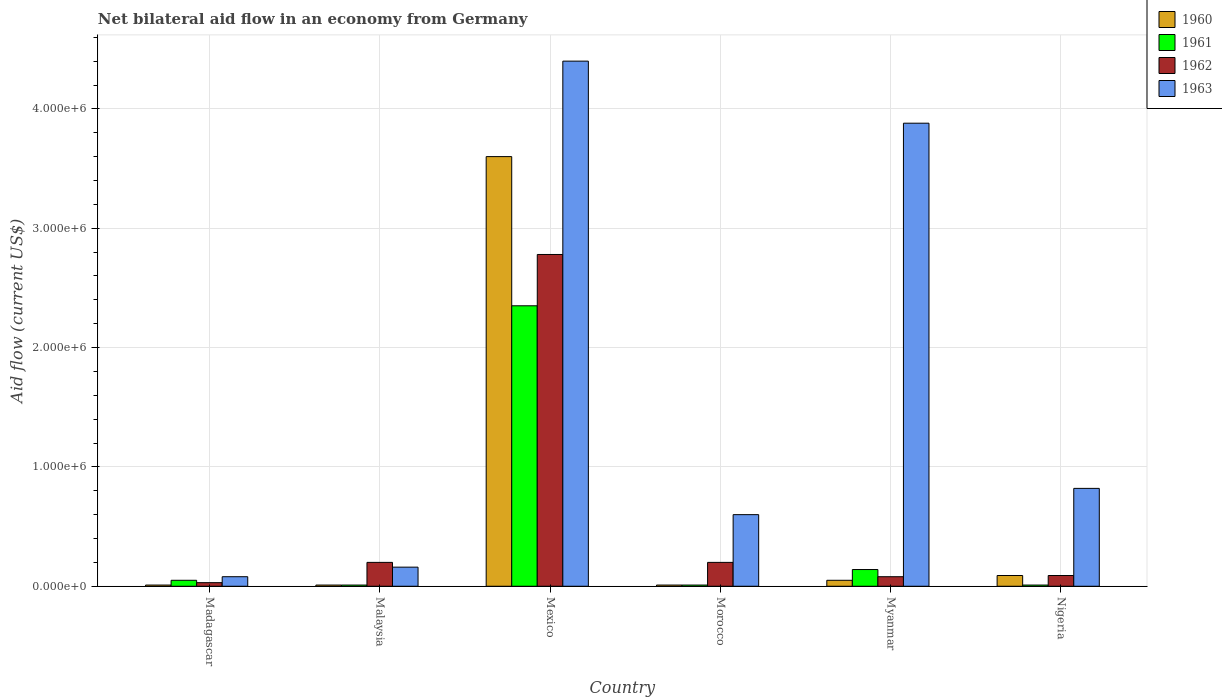Are the number of bars per tick equal to the number of legend labels?
Provide a succinct answer. Yes. What is the label of the 4th group of bars from the left?
Ensure brevity in your answer.  Morocco. What is the net bilateral aid flow in 1963 in Mexico?
Offer a very short reply. 4.40e+06. Across all countries, what is the maximum net bilateral aid flow in 1962?
Ensure brevity in your answer.  2.78e+06. In which country was the net bilateral aid flow in 1963 minimum?
Your answer should be compact. Madagascar. What is the total net bilateral aid flow in 1961 in the graph?
Provide a succinct answer. 2.57e+06. What is the difference between the net bilateral aid flow in 1962 in Madagascar and that in Malaysia?
Offer a terse response. -1.70e+05. What is the difference between the net bilateral aid flow in 1961 in Mexico and the net bilateral aid flow in 1960 in Morocco?
Provide a short and direct response. 2.34e+06. What is the average net bilateral aid flow in 1962 per country?
Provide a short and direct response. 5.63e+05. What is the difference between the net bilateral aid flow of/in 1963 and net bilateral aid flow of/in 1962 in Madagascar?
Offer a terse response. 5.00e+04. In how many countries, is the net bilateral aid flow in 1960 greater than 3000000 US$?
Offer a terse response. 1. What is the ratio of the net bilateral aid flow in 1960 in Madagascar to that in Nigeria?
Make the answer very short. 0.11. Is the difference between the net bilateral aid flow in 1963 in Malaysia and Nigeria greater than the difference between the net bilateral aid flow in 1962 in Malaysia and Nigeria?
Your answer should be compact. No. What is the difference between the highest and the second highest net bilateral aid flow in 1962?
Keep it short and to the point. 2.58e+06. What is the difference between the highest and the lowest net bilateral aid flow in 1961?
Your answer should be very brief. 2.34e+06. What does the 4th bar from the left in Madagascar represents?
Ensure brevity in your answer.  1963. What does the 1st bar from the right in Malaysia represents?
Offer a terse response. 1963. How many bars are there?
Your answer should be compact. 24. How many countries are there in the graph?
Ensure brevity in your answer.  6. What is the difference between two consecutive major ticks on the Y-axis?
Offer a very short reply. 1.00e+06. Are the values on the major ticks of Y-axis written in scientific E-notation?
Provide a short and direct response. Yes. Does the graph contain grids?
Provide a short and direct response. Yes. Where does the legend appear in the graph?
Give a very brief answer. Top right. How are the legend labels stacked?
Provide a succinct answer. Vertical. What is the title of the graph?
Provide a short and direct response. Net bilateral aid flow in an economy from Germany. What is the label or title of the Y-axis?
Keep it short and to the point. Aid flow (current US$). What is the Aid flow (current US$) in 1962 in Madagascar?
Make the answer very short. 3.00e+04. What is the Aid flow (current US$) in 1963 in Madagascar?
Provide a short and direct response. 8.00e+04. What is the Aid flow (current US$) in 1963 in Malaysia?
Your answer should be very brief. 1.60e+05. What is the Aid flow (current US$) of 1960 in Mexico?
Provide a short and direct response. 3.60e+06. What is the Aid flow (current US$) of 1961 in Mexico?
Your answer should be compact. 2.35e+06. What is the Aid flow (current US$) of 1962 in Mexico?
Make the answer very short. 2.78e+06. What is the Aid flow (current US$) of 1963 in Mexico?
Keep it short and to the point. 4.40e+06. What is the Aid flow (current US$) of 1961 in Morocco?
Ensure brevity in your answer.  10000. What is the Aid flow (current US$) in 1962 in Morocco?
Offer a terse response. 2.00e+05. What is the Aid flow (current US$) in 1963 in Morocco?
Provide a succinct answer. 6.00e+05. What is the Aid flow (current US$) in 1961 in Myanmar?
Your response must be concise. 1.40e+05. What is the Aid flow (current US$) in 1963 in Myanmar?
Ensure brevity in your answer.  3.88e+06. What is the Aid flow (current US$) of 1960 in Nigeria?
Provide a succinct answer. 9.00e+04. What is the Aid flow (current US$) in 1963 in Nigeria?
Keep it short and to the point. 8.20e+05. Across all countries, what is the maximum Aid flow (current US$) in 1960?
Provide a short and direct response. 3.60e+06. Across all countries, what is the maximum Aid flow (current US$) of 1961?
Keep it short and to the point. 2.35e+06. Across all countries, what is the maximum Aid flow (current US$) of 1962?
Make the answer very short. 2.78e+06. Across all countries, what is the maximum Aid flow (current US$) in 1963?
Provide a succinct answer. 4.40e+06. Across all countries, what is the minimum Aid flow (current US$) in 1962?
Your answer should be very brief. 3.00e+04. What is the total Aid flow (current US$) of 1960 in the graph?
Your response must be concise. 3.77e+06. What is the total Aid flow (current US$) in 1961 in the graph?
Make the answer very short. 2.57e+06. What is the total Aid flow (current US$) in 1962 in the graph?
Ensure brevity in your answer.  3.38e+06. What is the total Aid flow (current US$) in 1963 in the graph?
Offer a terse response. 9.94e+06. What is the difference between the Aid flow (current US$) of 1962 in Madagascar and that in Malaysia?
Ensure brevity in your answer.  -1.70e+05. What is the difference between the Aid flow (current US$) of 1963 in Madagascar and that in Malaysia?
Give a very brief answer. -8.00e+04. What is the difference between the Aid flow (current US$) in 1960 in Madagascar and that in Mexico?
Ensure brevity in your answer.  -3.59e+06. What is the difference between the Aid flow (current US$) of 1961 in Madagascar and that in Mexico?
Provide a succinct answer. -2.30e+06. What is the difference between the Aid flow (current US$) in 1962 in Madagascar and that in Mexico?
Offer a very short reply. -2.75e+06. What is the difference between the Aid flow (current US$) in 1963 in Madagascar and that in Mexico?
Offer a very short reply. -4.32e+06. What is the difference between the Aid flow (current US$) of 1961 in Madagascar and that in Morocco?
Provide a succinct answer. 4.00e+04. What is the difference between the Aid flow (current US$) of 1963 in Madagascar and that in Morocco?
Your answer should be very brief. -5.20e+05. What is the difference between the Aid flow (current US$) in 1960 in Madagascar and that in Myanmar?
Your answer should be compact. -4.00e+04. What is the difference between the Aid flow (current US$) of 1961 in Madagascar and that in Myanmar?
Your answer should be compact. -9.00e+04. What is the difference between the Aid flow (current US$) of 1962 in Madagascar and that in Myanmar?
Keep it short and to the point. -5.00e+04. What is the difference between the Aid flow (current US$) of 1963 in Madagascar and that in Myanmar?
Your answer should be compact. -3.80e+06. What is the difference between the Aid flow (current US$) of 1960 in Madagascar and that in Nigeria?
Make the answer very short. -8.00e+04. What is the difference between the Aid flow (current US$) of 1961 in Madagascar and that in Nigeria?
Give a very brief answer. 4.00e+04. What is the difference between the Aid flow (current US$) of 1963 in Madagascar and that in Nigeria?
Provide a short and direct response. -7.40e+05. What is the difference between the Aid flow (current US$) of 1960 in Malaysia and that in Mexico?
Offer a very short reply. -3.59e+06. What is the difference between the Aid flow (current US$) of 1961 in Malaysia and that in Mexico?
Ensure brevity in your answer.  -2.34e+06. What is the difference between the Aid flow (current US$) in 1962 in Malaysia and that in Mexico?
Provide a succinct answer. -2.58e+06. What is the difference between the Aid flow (current US$) of 1963 in Malaysia and that in Mexico?
Give a very brief answer. -4.24e+06. What is the difference between the Aid flow (current US$) in 1961 in Malaysia and that in Morocco?
Your answer should be very brief. 0. What is the difference between the Aid flow (current US$) of 1963 in Malaysia and that in Morocco?
Provide a short and direct response. -4.40e+05. What is the difference between the Aid flow (current US$) of 1960 in Malaysia and that in Myanmar?
Provide a short and direct response. -4.00e+04. What is the difference between the Aid flow (current US$) of 1961 in Malaysia and that in Myanmar?
Offer a very short reply. -1.30e+05. What is the difference between the Aid flow (current US$) of 1962 in Malaysia and that in Myanmar?
Offer a terse response. 1.20e+05. What is the difference between the Aid flow (current US$) of 1963 in Malaysia and that in Myanmar?
Your response must be concise. -3.72e+06. What is the difference between the Aid flow (current US$) of 1963 in Malaysia and that in Nigeria?
Give a very brief answer. -6.60e+05. What is the difference between the Aid flow (current US$) of 1960 in Mexico and that in Morocco?
Offer a terse response. 3.59e+06. What is the difference between the Aid flow (current US$) of 1961 in Mexico and that in Morocco?
Make the answer very short. 2.34e+06. What is the difference between the Aid flow (current US$) of 1962 in Mexico and that in Morocco?
Your response must be concise. 2.58e+06. What is the difference between the Aid flow (current US$) in 1963 in Mexico and that in Morocco?
Ensure brevity in your answer.  3.80e+06. What is the difference between the Aid flow (current US$) of 1960 in Mexico and that in Myanmar?
Your answer should be compact. 3.55e+06. What is the difference between the Aid flow (current US$) of 1961 in Mexico and that in Myanmar?
Offer a very short reply. 2.21e+06. What is the difference between the Aid flow (current US$) of 1962 in Mexico and that in Myanmar?
Keep it short and to the point. 2.70e+06. What is the difference between the Aid flow (current US$) in 1963 in Mexico and that in Myanmar?
Ensure brevity in your answer.  5.20e+05. What is the difference between the Aid flow (current US$) of 1960 in Mexico and that in Nigeria?
Ensure brevity in your answer.  3.51e+06. What is the difference between the Aid flow (current US$) of 1961 in Mexico and that in Nigeria?
Offer a very short reply. 2.34e+06. What is the difference between the Aid flow (current US$) in 1962 in Mexico and that in Nigeria?
Provide a succinct answer. 2.69e+06. What is the difference between the Aid flow (current US$) of 1963 in Mexico and that in Nigeria?
Your response must be concise. 3.58e+06. What is the difference between the Aid flow (current US$) in 1961 in Morocco and that in Myanmar?
Give a very brief answer. -1.30e+05. What is the difference between the Aid flow (current US$) in 1962 in Morocco and that in Myanmar?
Your answer should be compact. 1.20e+05. What is the difference between the Aid flow (current US$) in 1963 in Morocco and that in Myanmar?
Keep it short and to the point. -3.28e+06. What is the difference between the Aid flow (current US$) of 1960 in Morocco and that in Nigeria?
Give a very brief answer. -8.00e+04. What is the difference between the Aid flow (current US$) in 1961 in Morocco and that in Nigeria?
Your response must be concise. 0. What is the difference between the Aid flow (current US$) in 1963 in Morocco and that in Nigeria?
Provide a succinct answer. -2.20e+05. What is the difference between the Aid flow (current US$) in 1961 in Myanmar and that in Nigeria?
Provide a short and direct response. 1.30e+05. What is the difference between the Aid flow (current US$) of 1962 in Myanmar and that in Nigeria?
Your response must be concise. -10000. What is the difference between the Aid flow (current US$) of 1963 in Myanmar and that in Nigeria?
Offer a very short reply. 3.06e+06. What is the difference between the Aid flow (current US$) in 1960 in Madagascar and the Aid flow (current US$) in 1961 in Malaysia?
Provide a succinct answer. 0. What is the difference between the Aid flow (current US$) of 1960 in Madagascar and the Aid flow (current US$) of 1962 in Malaysia?
Ensure brevity in your answer.  -1.90e+05. What is the difference between the Aid flow (current US$) in 1960 in Madagascar and the Aid flow (current US$) in 1963 in Malaysia?
Offer a very short reply. -1.50e+05. What is the difference between the Aid flow (current US$) of 1961 in Madagascar and the Aid flow (current US$) of 1962 in Malaysia?
Provide a succinct answer. -1.50e+05. What is the difference between the Aid flow (current US$) in 1962 in Madagascar and the Aid flow (current US$) in 1963 in Malaysia?
Your answer should be compact. -1.30e+05. What is the difference between the Aid flow (current US$) in 1960 in Madagascar and the Aid flow (current US$) in 1961 in Mexico?
Offer a very short reply. -2.34e+06. What is the difference between the Aid flow (current US$) of 1960 in Madagascar and the Aid flow (current US$) of 1962 in Mexico?
Offer a terse response. -2.77e+06. What is the difference between the Aid flow (current US$) in 1960 in Madagascar and the Aid flow (current US$) in 1963 in Mexico?
Your answer should be compact. -4.39e+06. What is the difference between the Aid flow (current US$) of 1961 in Madagascar and the Aid flow (current US$) of 1962 in Mexico?
Your answer should be compact. -2.73e+06. What is the difference between the Aid flow (current US$) in 1961 in Madagascar and the Aid flow (current US$) in 1963 in Mexico?
Offer a very short reply. -4.35e+06. What is the difference between the Aid flow (current US$) of 1962 in Madagascar and the Aid flow (current US$) of 1963 in Mexico?
Make the answer very short. -4.37e+06. What is the difference between the Aid flow (current US$) in 1960 in Madagascar and the Aid flow (current US$) in 1962 in Morocco?
Provide a short and direct response. -1.90e+05. What is the difference between the Aid flow (current US$) in 1960 in Madagascar and the Aid flow (current US$) in 1963 in Morocco?
Provide a succinct answer. -5.90e+05. What is the difference between the Aid flow (current US$) of 1961 in Madagascar and the Aid flow (current US$) of 1963 in Morocco?
Your response must be concise. -5.50e+05. What is the difference between the Aid flow (current US$) of 1962 in Madagascar and the Aid flow (current US$) of 1963 in Morocco?
Your response must be concise. -5.70e+05. What is the difference between the Aid flow (current US$) in 1960 in Madagascar and the Aid flow (current US$) in 1961 in Myanmar?
Keep it short and to the point. -1.30e+05. What is the difference between the Aid flow (current US$) of 1960 in Madagascar and the Aid flow (current US$) of 1963 in Myanmar?
Keep it short and to the point. -3.87e+06. What is the difference between the Aid flow (current US$) of 1961 in Madagascar and the Aid flow (current US$) of 1963 in Myanmar?
Your response must be concise. -3.83e+06. What is the difference between the Aid flow (current US$) in 1962 in Madagascar and the Aid flow (current US$) in 1963 in Myanmar?
Provide a short and direct response. -3.85e+06. What is the difference between the Aid flow (current US$) of 1960 in Madagascar and the Aid flow (current US$) of 1961 in Nigeria?
Offer a very short reply. 0. What is the difference between the Aid flow (current US$) of 1960 in Madagascar and the Aid flow (current US$) of 1963 in Nigeria?
Provide a succinct answer. -8.10e+05. What is the difference between the Aid flow (current US$) in 1961 in Madagascar and the Aid flow (current US$) in 1962 in Nigeria?
Your answer should be very brief. -4.00e+04. What is the difference between the Aid flow (current US$) in 1961 in Madagascar and the Aid flow (current US$) in 1963 in Nigeria?
Keep it short and to the point. -7.70e+05. What is the difference between the Aid flow (current US$) of 1962 in Madagascar and the Aid flow (current US$) of 1963 in Nigeria?
Provide a short and direct response. -7.90e+05. What is the difference between the Aid flow (current US$) of 1960 in Malaysia and the Aid flow (current US$) of 1961 in Mexico?
Provide a short and direct response. -2.34e+06. What is the difference between the Aid flow (current US$) of 1960 in Malaysia and the Aid flow (current US$) of 1962 in Mexico?
Offer a terse response. -2.77e+06. What is the difference between the Aid flow (current US$) in 1960 in Malaysia and the Aid flow (current US$) in 1963 in Mexico?
Your response must be concise. -4.39e+06. What is the difference between the Aid flow (current US$) of 1961 in Malaysia and the Aid flow (current US$) of 1962 in Mexico?
Your answer should be very brief. -2.77e+06. What is the difference between the Aid flow (current US$) in 1961 in Malaysia and the Aid flow (current US$) in 1963 in Mexico?
Ensure brevity in your answer.  -4.39e+06. What is the difference between the Aid flow (current US$) in 1962 in Malaysia and the Aid flow (current US$) in 1963 in Mexico?
Ensure brevity in your answer.  -4.20e+06. What is the difference between the Aid flow (current US$) of 1960 in Malaysia and the Aid flow (current US$) of 1961 in Morocco?
Your answer should be compact. 0. What is the difference between the Aid flow (current US$) in 1960 in Malaysia and the Aid flow (current US$) in 1963 in Morocco?
Your response must be concise. -5.90e+05. What is the difference between the Aid flow (current US$) in 1961 in Malaysia and the Aid flow (current US$) in 1962 in Morocco?
Ensure brevity in your answer.  -1.90e+05. What is the difference between the Aid flow (current US$) in 1961 in Malaysia and the Aid flow (current US$) in 1963 in Morocco?
Your response must be concise. -5.90e+05. What is the difference between the Aid flow (current US$) of 1962 in Malaysia and the Aid flow (current US$) of 1963 in Morocco?
Provide a succinct answer. -4.00e+05. What is the difference between the Aid flow (current US$) in 1960 in Malaysia and the Aid flow (current US$) in 1961 in Myanmar?
Your response must be concise. -1.30e+05. What is the difference between the Aid flow (current US$) of 1960 in Malaysia and the Aid flow (current US$) of 1962 in Myanmar?
Give a very brief answer. -7.00e+04. What is the difference between the Aid flow (current US$) of 1960 in Malaysia and the Aid flow (current US$) of 1963 in Myanmar?
Offer a terse response. -3.87e+06. What is the difference between the Aid flow (current US$) in 1961 in Malaysia and the Aid flow (current US$) in 1962 in Myanmar?
Ensure brevity in your answer.  -7.00e+04. What is the difference between the Aid flow (current US$) of 1961 in Malaysia and the Aid flow (current US$) of 1963 in Myanmar?
Your response must be concise. -3.87e+06. What is the difference between the Aid flow (current US$) in 1962 in Malaysia and the Aid flow (current US$) in 1963 in Myanmar?
Ensure brevity in your answer.  -3.68e+06. What is the difference between the Aid flow (current US$) of 1960 in Malaysia and the Aid flow (current US$) of 1961 in Nigeria?
Keep it short and to the point. 0. What is the difference between the Aid flow (current US$) in 1960 in Malaysia and the Aid flow (current US$) in 1962 in Nigeria?
Offer a very short reply. -8.00e+04. What is the difference between the Aid flow (current US$) of 1960 in Malaysia and the Aid flow (current US$) of 1963 in Nigeria?
Your answer should be compact. -8.10e+05. What is the difference between the Aid flow (current US$) in 1961 in Malaysia and the Aid flow (current US$) in 1963 in Nigeria?
Provide a succinct answer. -8.10e+05. What is the difference between the Aid flow (current US$) in 1962 in Malaysia and the Aid flow (current US$) in 1963 in Nigeria?
Provide a succinct answer. -6.20e+05. What is the difference between the Aid flow (current US$) in 1960 in Mexico and the Aid flow (current US$) in 1961 in Morocco?
Keep it short and to the point. 3.59e+06. What is the difference between the Aid flow (current US$) of 1960 in Mexico and the Aid flow (current US$) of 1962 in Morocco?
Give a very brief answer. 3.40e+06. What is the difference between the Aid flow (current US$) in 1960 in Mexico and the Aid flow (current US$) in 1963 in Morocco?
Make the answer very short. 3.00e+06. What is the difference between the Aid flow (current US$) of 1961 in Mexico and the Aid flow (current US$) of 1962 in Morocco?
Ensure brevity in your answer.  2.15e+06. What is the difference between the Aid flow (current US$) in 1961 in Mexico and the Aid flow (current US$) in 1963 in Morocco?
Give a very brief answer. 1.75e+06. What is the difference between the Aid flow (current US$) of 1962 in Mexico and the Aid flow (current US$) of 1963 in Morocco?
Your response must be concise. 2.18e+06. What is the difference between the Aid flow (current US$) in 1960 in Mexico and the Aid flow (current US$) in 1961 in Myanmar?
Give a very brief answer. 3.46e+06. What is the difference between the Aid flow (current US$) of 1960 in Mexico and the Aid flow (current US$) of 1962 in Myanmar?
Provide a short and direct response. 3.52e+06. What is the difference between the Aid flow (current US$) in 1960 in Mexico and the Aid flow (current US$) in 1963 in Myanmar?
Offer a very short reply. -2.80e+05. What is the difference between the Aid flow (current US$) in 1961 in Mexico and the Aid flow (current US$) in 1962 in Myanmar?
Offer a very short reply. 2.27e+06. What is the difference between the Aid flow (current US$) of 1961 in Mexico and the Aid flow (current US$) of 1963 in Myanmar?
Give a very brief answer. -1.53e+06. What is the difference between the Aid flow (current US$) in 1962 in Mexico and the Aid flow (current US$) in 1963 in Myanmar?
Your answer should be compact. -1.10e+06. What is the difference between the Aid flow (current US$) of 1960 in Mexico and the Aid flow (current US$) of 1961 in Nigeria?
Your response must be concise. 3.59e+06. What is the difference between the Aid flow (current US$) in 1960 in Mexico and the Aid flow (current US$) in 1962 in Nigeria?
Offer a very short reply. 3.51e+06. What is the difference between the Aid flow (current US$) in 1960 in Mexico and the Aid flow (current US$) in 1963 in Nigeria?
Your answer should be compact. 2.78e+06. What is the difference between the Aid flow (current US$) of 1961 in Mexico and the Aid flow (current US$) of 1962 in Nigeria?
Give a very brief answer. 2.26e+06. What is the difference between the Aid flow (current US$) of 1961 in Mexico and the Aid flow (current US$) of 1963 in Nigeria?
Make the answer very short. 1.53e+06. What is the difference between the Aid flow (current US$) in 1962 in Mexico and the Aid flow (current US$) in 1963 in Nigeria?
Make the answer very short. 1.96e+06. What is the difference between the Aid flow (current US$) of 1960 in Morocco and the Aid flow (current US$) of 1961 in Myanmar?
Your answer should be very brief. -1.30e+05. What is the difference between the Aid flow (current US$) in 1960 in Morocco and the Aid flow (current US$) in 1963 in Myanmar?
Ensure brevity in your answer.  -3.87e+06. What is the difference between the Aid flow (current US$) of 1961 in Morocco and the Aid flow (current US$) of 1962 in Myanmar?
Provide a short and direct response. -7.00e+04. What is the difference between the Aid flow (current US$) in 1961 in Morocco and the Aid flow (current US$) in 1963 in Myanmar?
Your answer should be compact. -3.87e+06. What is the difference between the Aid flow (current US$) of 1962 in Morocco and the Aid flow (current US$) of 1963 in Myanmar?
Your answer should be very brief. -3.68e+06. What is the difference between the Aid flow (current US$) in 1960 in Morocco and the Aid flow (current US$) in 1962 in Nigeria?
Make the answer very short. -8.00e+04. What is the difference between the Aid flow (current US$) of 1960 in Morocco and the Aid flow (current US$) of 1963 in Nigeria?
Your response must be concise. -8.10e+05. What is the difference between the Aid flow (current US$) in 1961 in Morocco and the Aid flow (current US$) in 1963 in Nigeria?
Your answer should be compact. -8.10e+05. What is the difference between the Aid flow (current US$) of 1962 in Morocco and the Aid flow (current US$) of 1963 in Nigeria?
Give a very brief answer. -6.20e+05. What is the difference between the Aid flow (current US$) in 1960 in Myanmar and the Aid flow (current US$) in 1961 in Nigeria?
Provide a succinct answer. 4.00e+04. What is the difference between the Aid flow (current US$) in 1960 in Myanmar and the Aid flow (current US$) in 1962 in Nigeria?
Your answer should be compact. -4.00e+04. What is the difference between the Aid flow (current US$) in 1960 in Myanmar and the Aid flow (current US$) in 1963 in Nigeria?
Your answer should be very brief. -7.70e+05. What is the difference between the Aid flow (current US$) in 1961 in Myanmar and the Aid flow (current US$) in 1962 in Nigeria?
Provide a succinct answer. 5.00e+04. What is the difference between the Aid flow (current US$) in 1961 in Myanmar and the Aid flow (current US$) in 1963 in Nigeria?
Offer a very short reply. -6.80e+05. What is the difference between the Aid flow (current US$) of 1962 in Myanmar and the Aid flow (current US$) of 1963 in Nigeria?
Keep it short and to the point. -7.40e+05. What is the average Aid flow (current US$) of 1960 per country?
Provide a short and direct response. 6.28e+05. What is the average Aid flow (current US$) of 1961 per country?
Give a very brief answer. 4.28e+05. What is the average Aid flow (current US$) in 1962 per country?
Offer a very short reply. 5.63e+05. What is the average Aid flow (current US$) in 1963 per country?
Offer a terse response. 1.66e+06. What is the difference between the Aid flow (current US$) of 1960 and Aid flow (current US$) of 1962 in Madagascar?
Offer a terse response. -2.00e+04. What is the difference between the Aid flow (current US$) in 1960 and Aid flow (current US$) in 1963 in Madagascar?
Give a very brief answer. -7.00e+04. What is the difference between the Aid flow (current US$) of 1961 and Aid flow (current US$) of 1962 in Malaysia?
Your response must be concise. -1.90e+05. What is the difference between the Aid flow (current US$) in 1960 and Aid flow (current US$) in 1961 in Mexico?
Your answer should be compact. 1.25e+06. What is the difference between the Aid flow (current US$) of 1960 and Aid flow (current US$) of 1962 in Mexico?
Offer a very short reply. 8.20e+05. What is the difference between the Aid flow (current US$) of 1960 and Aid flow (current US$) of 1963 in Mexico?
Offer a very short reply. -8.00e+05. What is the difference between the Aid flow (current US$) in 1961 and Aid flow (current US$) in 1962 in Mexico?
Your response must be concise. -4.30e+05. What is the difference between the Aid flow (current US$) in 1961 and Aid flow (current US$) in 1963 in Mexico?
Your answer should be very brief. -2.05e+06. What is the difference between the Aid flow (current US$) of 1962 and Aid flow (current US$) of 1963 in Mexico?
Ensure brevity in your answer.  -1.62e+06. What is the difference between the Aid flow (current US$) of 1960 and Aid flow (current US$) of 1961 in Morocco?
Keep it short and to the point. 0. What is the difference between the Aid flow (current US$) of 1960 and Aid flow (current US$) of 1962 in Morocco?
Provide a succinct answer. -1.90e+05. What is the difference between the Aid flow (current US$) of 1960 and Aid flow (current US$) of 1963 in Morocco?
Your answer should be very brief. -5.90e+05. What is the difference between the Aid flow (current US$) in 1961 and Aid flow (current US$) in 1963 in Morocco?
Offer a very short reply. -5.90e+05. What is the difference between the Aid flow (current US$) in 1962 and Aid flow (current US$) in 1963 in Morocco?
Provide a short and direct response. -4.00e+05. What is the difference between the Aid flow (current US$) of 1960 and Aid flow (current US$) of 1962 in Myanmar?
Provide a short and direct response. -3.00e+04. What is the difference between the Aid flow (current US$) of 1960 and Aid flow (current US$) of 1963 in Myanmar?
Make the answer very short. -3.83e+06. What is the difference between the Aid flow (current US$) in 1961 and Aid flow (current US$) in 1962 in Myanmar?
Ensure brevity in your answer.  6.00e+04. What is the difference between the Aid flow (current US$) of 1961 and Aid flow (current US$) of 1963 in Myanmar?
Your response must be concise. -3.74e+06. What is the difference between the Aid flow (current US$) in 1962 and Aid flow (current US$) in 1963 in Myanmar?
Your answer should be compact. -3.80e+06. What is the difference between the Aid flow (current US$) of 1960 and Aid flow (current US$) of 1961 in Nigeria?
Make the answer very short. 8.00e+04. What is the difference between the Aid flow (current US$) in 1960 and Aid flow (current US$) in 1963 in Nigeria?
Offer a terse response. -7.30e+05. What is the difference between the Aid flow (current US$) in 1961 and Aid flow (current US$) in 1963 in Nigeria?
Give a very brief answer. -8.10e+05. What is the difference between the Aid flow (current US$) in 1962 and Aid flow (current US$) in 1963 in Nigeria?
Offer a very short reply. -7.30e+05. What is the ratio of the Aid flow (current US$) of 1960 in Madagascar to that in Malaysia?
Make the answer very short. 1. What is the ratio of the Aid flow (current US$) of 1961 in Madagascar to that in Malaysia?
Your response must be concise. 5. What is the ratio of the Aid flow (current US$) of 1960 in Madagascar to that in Mexico?
Provide a succinct answer. 0. What is the ratio of the Aid flow (current US$) in 1961 in Madagascar to that in Mexico?
Provide a succinct answer. 0.02. What is the ratio of the Aid flow (current US$) in 1962 in Madagascar to that in Mexico?
Offer a very short reply. 0.01. What is the ratio of the Aid flow (current US$) in 1963 in Madagascar to that in Mexico?
Provide a short and direct response. 0.02. What is the ratio of the Aid flow (current US$) of 1962 in Madagascar to that in Morocco?
Offer a very short reply. 0.15. What is the ratio of the Aid flow (current US$) in 1963 in Madagascar to that in Morocco?
Your response must be concise. 0.13. What is the ratio of the Aid flow (current US$) in 1961 in Madagascar to that in Myanmar?
Your response must be concise. 0.36. What is the ratio of the Aid flow (current US$) in 1962 in Madagascar to that in Myanmar?
Provide a short and direct response. 0.38. What is the ratio of the Aid flow (current US$) in 1963 in Madagascar to that in Myanmar?
Your answer should be very brief. 0.02. What is the ratio of the Aid flow (current US$) of 1961 in Madagascar to that in Nigeria?
Your answer should be very brief. 5. What is the ratio of the Aid flow (current US$) in 1963 in Madagascar to that in Nigeria?
Provide a short and direct response. 0.1. What is the ratio of the Aid flow (current US$) of 1960 in Malaysia to that in Mexico?
Your answer should be very brief. 0. What is the ratio of the Aid flow (current US$) in 1961 in Malaysia to that in Mexico?
Offer a terse response. 0. What is the ratio of the Aid flow (current US$) in 1962 in Malaysia to that in Mexico?
Offer a terse response. 0.07. What is the ratio of the Aid flow (current US$) in 1963 in Malaysia to that in Mexico?
Offer a very short reply. 0.04. What is the ratio of the Aid flow (current US$) of 1961 in Malaysia to that in Morocco?
Make the answer very short. 1. What is the ratio of the Aid flow (current US$) in 1962 in Malaysia to that in Morocco?
Give a very brief answer. 1. What is the ratio of the Aid flow (current US$) in 1963 in Malaysia to that in Morocco?
Make the answer very short. 0.27. What is the ratio of the Aid flow (current US$) of 1960 in Malaysia to that in Myanmar?
Provide a short and direct response. 0.2. What is the ratio of the Aid flow (current US$) of 1961 in Malaysia to that in Myanmar?
Ensure brevity in your answer.  0.07. What is the ratio of the Aid flow (current US$) of 1962 in Malaysia to that in Myanmar?
Give a very brief answer. 2.5. What is the ratio of the Aid flow (current US$) of 1963 in Malaysia to that in Myanmar?
Offer a very short reply. 0.04. What is the ratio of the Aid flow (current US$) in 1961 in Malaysia to that in Nigeria?
Offer a terse response. 1. What is the ratio of the Aid flow (current US$) of 1962 in Malaysia to that in Nigeria?
Offer a very short reply. 2.22. What is the ratio of the Aid flow (current US$) in 1963 in Malaysia to that in Nigeria?
Keep it short and to the point. 0.2. What is the ratio of the Aid flow (current US$) in 1960 in Mexico to that in Morocco?
Ensure brevity in your answer.  360. What is the ratio of the Aid flow (current US$) in 1961 in Mexico to that in Morocco?
Your answer should be compact. 235. What is the ratio of the Aid flow (current US$) of 1963 in Mexico to that in Morocco?
Your response must be concise. 7.33. What is the ratio of the Aid flow (current US$) of 1960 in Mexico to that in Myanmar?
Keep it short and to the point. 72. What is the ratio of the Aid flow (current US$) of 1961 in Mexico to that in Myanmar?
Keep it short and to the point. 16.79. What is the ratio of the Aid flow (current US$) of 1962 in Mexico to that in Myanmar?
Ensure brevity in your answer.  34.75. What is the ratio of the Aid flow (current US$) in 1963 in Mexico to that in Myanmar?
Provide a succinct answer. 1.13. What is the ratio of the Aid flow (current US$) in 1960 in Mexico to that in Nigeria?
Offer a terse response. 40. What is the ratio of the Aid flow (current US$) in 1961 in Mexico to that in Nigeria?
Your answer should be very brief. 235. What is the ratio of the Aid flow (current US$) of 1962 in Mexico to that in Nigeria?
Provide a succinct answer. 30.89. What is the ratio of the Aid flow (current US$) in 1963 in Mexico to that in Nigeria?
Offer a very short reply. 5.37. What is the ratio of the Aid flow (current US$) of 1960 in Morocco to that in Myanmar?
Give a very brief answer. 0.2. What is the ratio of the Aid flow (current US$) of 1961 in Morocco to that in Myanmar?
Your answer should be compact. 0.07. What is the ratio of the Aid flow (current US$) of 1962 in Morocco to that in Myanmar?
Give a very brief answer. 2.5. What is the ratio of the Aid flow (current US$) in 1963 in Morocco to that in Myanmar?
Make the answer very short. 0.15. What is the ratio of the Aid flow (current US$) of 1961 in Morocco to that in Nigeria?
Provide a succinct answer. 1. What is the ratio of the Aid flow (current US$) of 1962 in Morocco to that in Nigeria?
Your answer should be compact. 2.22. What is the ratio of the Aid flow (current US$) in 1963 in Morocco to that in Nigeria?
Ensure brevity in your answer.  0.73. What is the ratio of the Aid flow (current US$) of 1960 in Myanmar to that in Nigeria?
Make the answer very short. 0.56. What is the ratio of the Aid flow (current US$) of 1963 in Myanmar to that in Nigeria?
Keep it short and to the point. 4.73. What is the difference between the highest and the second highest Aid flow (current US$) in 1960?
Your response must be concise. 3.51e+06. What is the difference between the highest and the second highest Aid flow (current US$) in 1961?
Offer a terse response. 2.21e+06. What is the difference between the highest and the second highest Aid flow (current US$) of 1962?
Ensure brevity in your answer.  2.58e+06. What is the difference between the highest and the second highest Aid flow (current US$) of 1963?
Your response must be concise. 5.20e+05. What is the difference between the highest and the lowest Aid flow (current US$) in 1960?
Give a very brief answer. 3.59e+06. What is the difference between the highest and the lowest Aid flow (current US$) in 1961?
Provide a succinct answer. 2.34e+06. What is the difference between the highest and the lowest Aid flow (current US$) in 1962?
Ensure brevity in your answer.  2.75e+06. What is the difference between the highest and the lowest Aid flow (current US$) in 1963?
Give a very brief answer. 4.32e+06. 